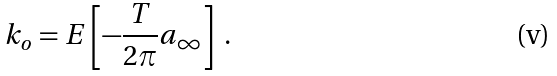Convert formula to latex. <formula><loc_0><loc_0><loc_500><loc_500>k _ { o } = E \left [ - \frac { T } { 2 \pi } a _ { \infty } \right ] \ .</formula> 